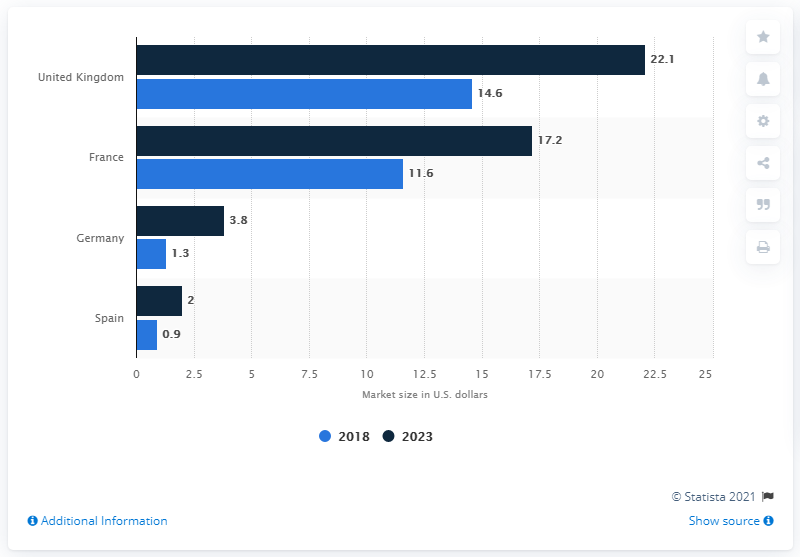Draw attention to some important aspects in this diagram. According to recent data, the value of the German online grocery market is estimated to be 3.8 billion U.S. dollars. In 2018, the total market size in Spain was approximately 2.9 billion dollars. The estimated value of the German online grocery market is 1.3 billion US dollars. In 2018, the market size of Spain was 0.9 billion U.S. dollars. The German online grocery market is valued at 3.8 billion U.S. dollars. 